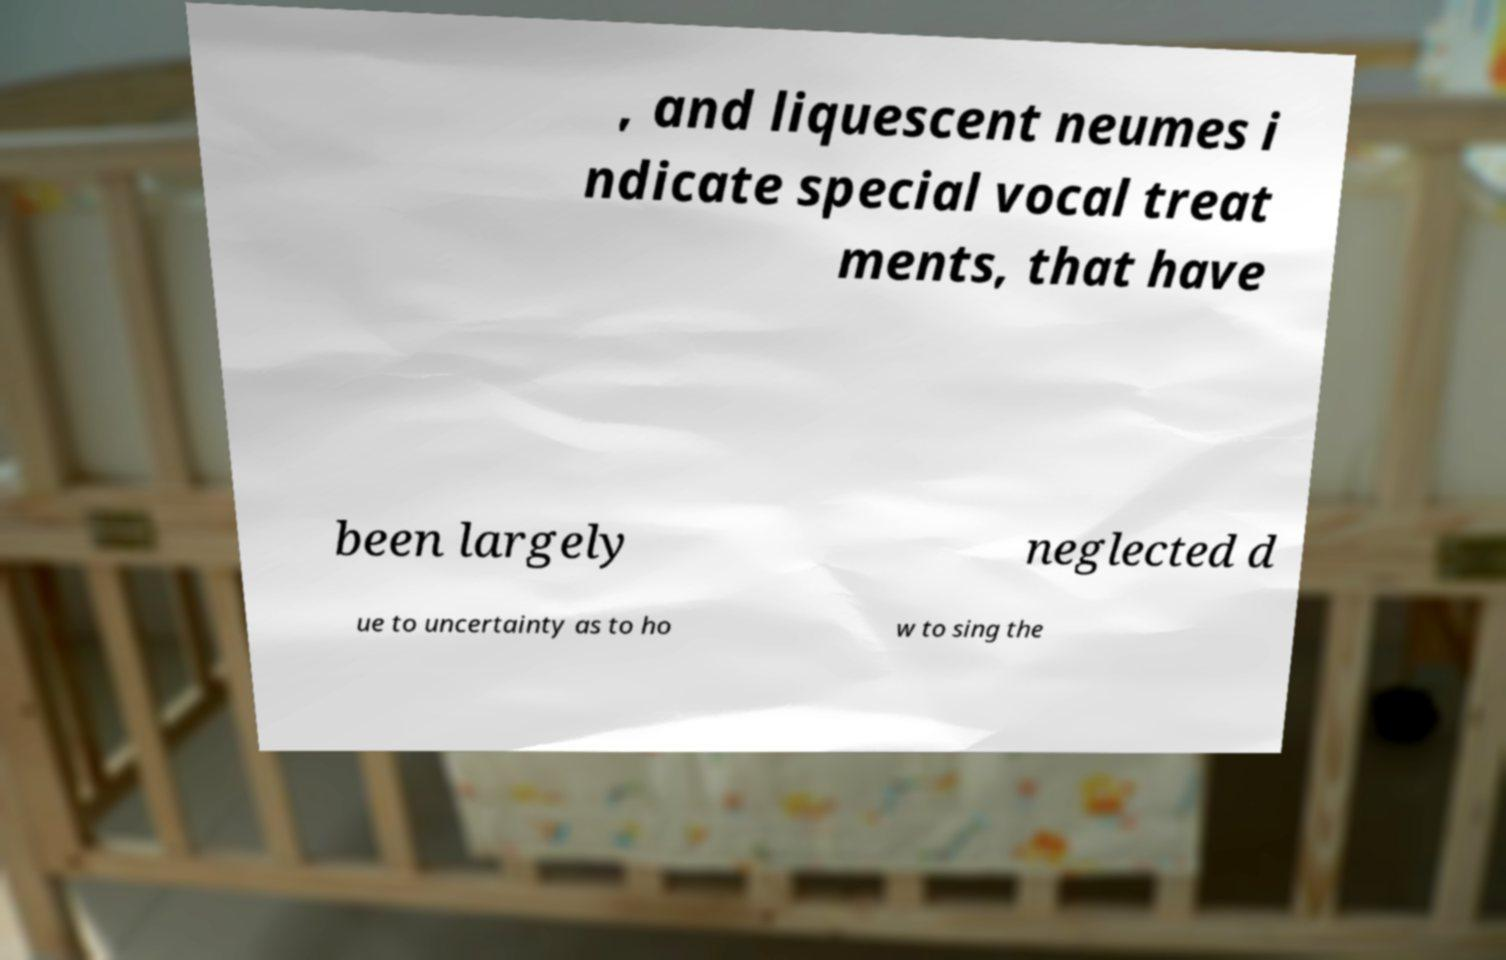Could you assist in decoding the text presented in this image and type it out clearly? , and liquescent neumes i ndicate special vocal treat ments, that have been largely neglected d ue to uncertainty as to ho w to sing the 